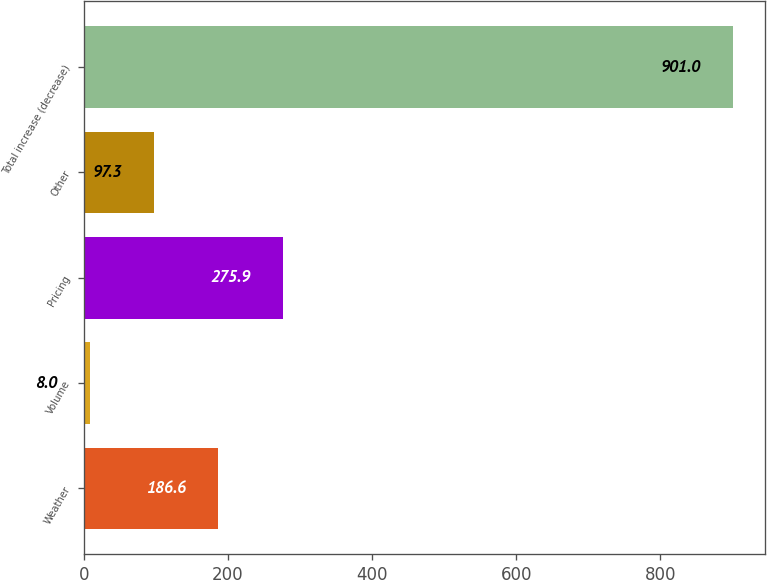<chart> <loc_0><loc_0><loc_500><loc_500><bar_chart><fcel>Weather<fcel>Volume<fcel>Pricing<fcel>Other<fcel>Total increase (decrease)<nl><fcel>186.6<fcel>8<fcel>275.9<fcel>97.3<fcel>901<nl></chart> 